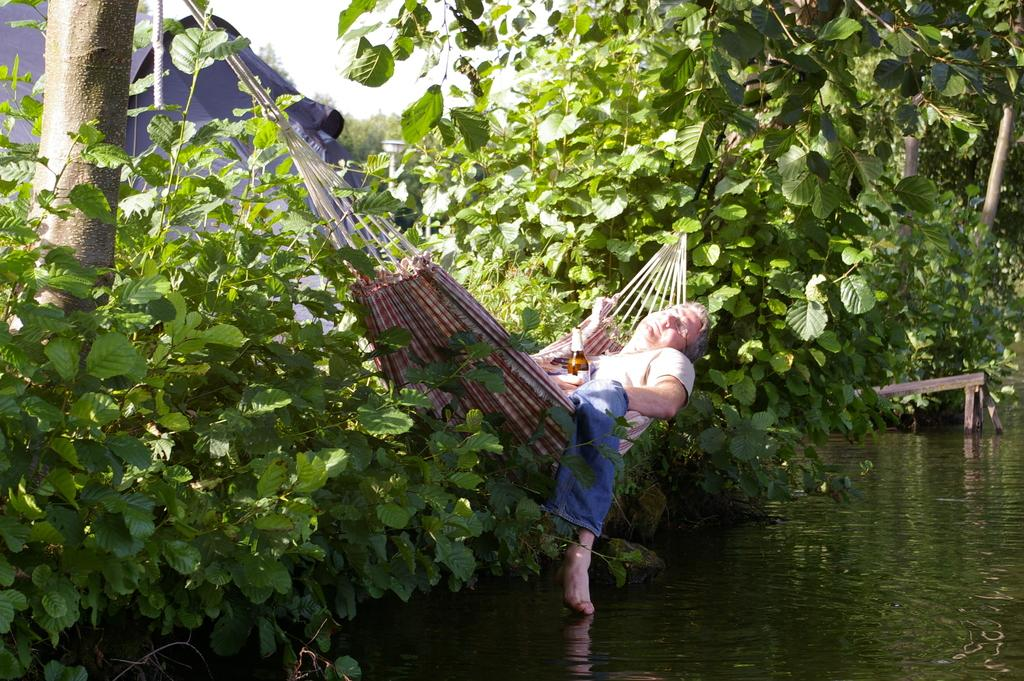What is the main object in the image? There is a swing in the image. Who is using the swing? There is a person on the swing. What can be seen near the swing? There is a bottle in the image. What is the natural setting in the image? Water, trees, and the sky are visible in the background of the image. What else can be seen in the background of the image? There are tents and a pole in the background of the image. What type of curtain is hanging from the swing in the image? There is no curtain hanging from the swing in the image. 